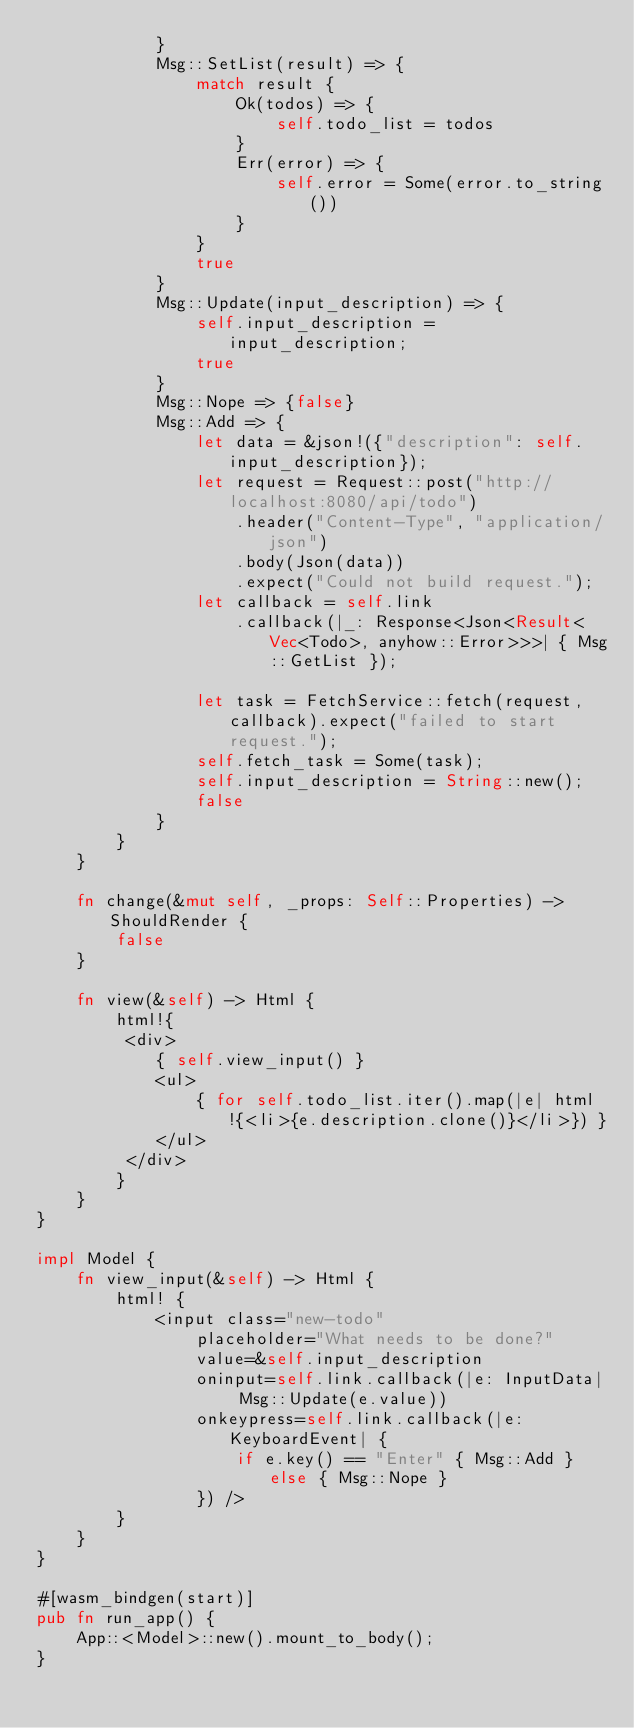<code> <loc_0><loc_0><loc_500><loc_500><_Rust_>            }
            Msg::SetList(result) => {
                match result {
                    Ok(todos) => {
                        self.todo_list = todos
                    }
                    Err(error) => {
                        self.error = Some(error.to_string())
                    }
                }
                true
            }
            Msg::Update(input_description) => {
                self.input_description = input_description;
                true
            }
            Msg::Nope => {false}
            Msg::Add => {
                let data = &json!({"description": self.input_description});
                let request = Request::post("http://localhost:8080/api/todo")
                    .header("Content-Type", "application/json")
                    .body(Json(data))
                    .expect("Could not build request.");
                let callback = self.link
                    .callback(|_: Response<Json<Result<Vec<Todo>, anyhow::Error>>>| { Msg::GetList });

                let task = FetchService::fetch(request, callback).expect("failed to start request.");
                self.fetch_task = Some(task);
                self.input_description = String::new();
                false
            }
        }
    }

    fn change(&mut self, _props: Self::Properties) -> ShouldRender {
        false
    }

    fn view(&self) -> Html {
        html!{
         <div>
            { self.view_input() }
            <ul>
                { for self.todo_list.iter().map(|e| html!{<li>{e.description.clone()}</li>}) }
            </ul>
         </div>
        }
    }
}

impl Model {
    fn view_input(&self) -> Html {
        html! {
            <input class="new-todo"
                placeholder="What needs to be done?"
                value=&self.input_description
                oninput=self.link.callback(|e: InputData| Msg::Update(e.value))
                onkeypress=self.link.callback(|e: KeyboardEvent| {
                    if e.key() == "Enter" { Msg::Add } else { Msg::Nope }
                }) />
        }
    }
}

#[wasm_bindgen(start)]
pub fn run_app() {
    App::<Model>::new().mount_to_body();
}
</code> 